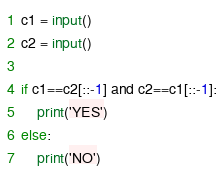Convert code to text. <code><loc_0><loc_0><loc_500><loc_500><_Python_>c1 = input()
c2 = input()

if c1==c2[::-1] and c2==c1[::-1]:
    print('YES')
else:
    print('NO')</code> 